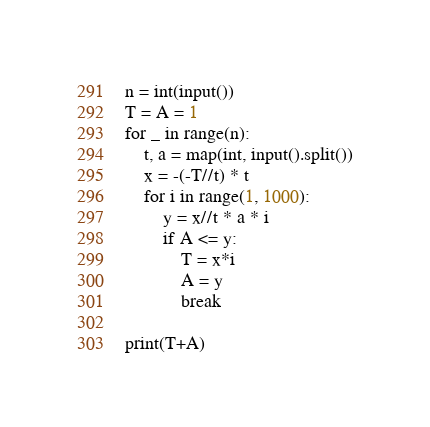Convert code to text. <code><loc_0><loc_0><loc_500><loc_500><_Python_>n = int(input())
T = A = 1
for _ in range(n):
    t, a = map(int, input().split())
    x = -(-T//t) * t
    for i in range(1, 1000):
        y = x//t * a * i
        if A <= y:
            T = x*i
            A = y
            break

print(T+A)
</code> 